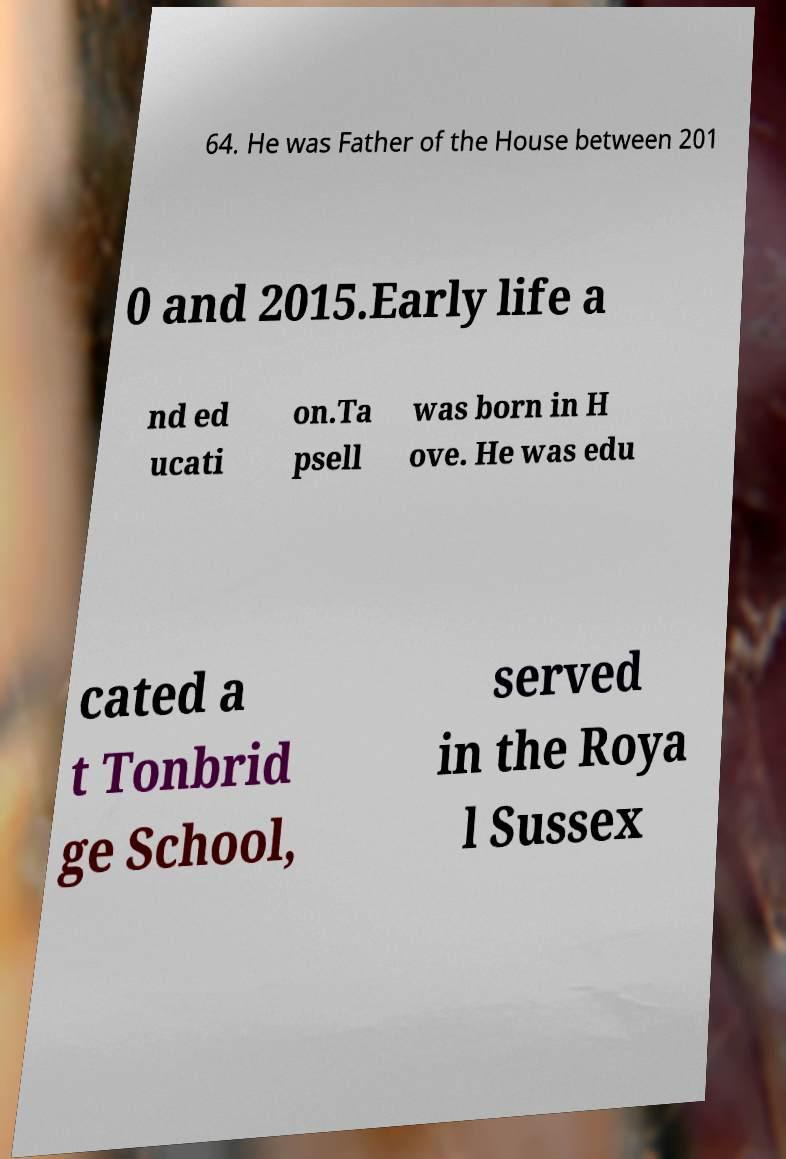Please read and relay the text visible in this image. What does it say? 64. He was Father of the House between 201 0 and 2015.Early life a nd ed ucati on.Ta psell was born in H ove. He was edu cated a t Tonbrid ge School, served in the Roya l Sussex 